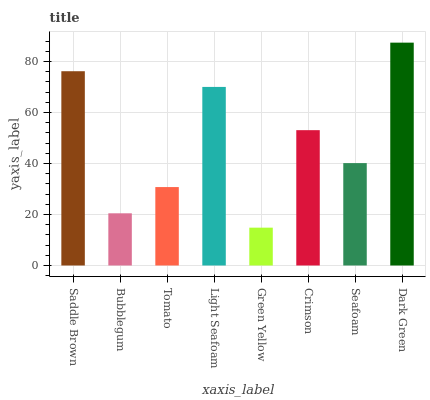Is Green Yellow the minimum?
Answer yes or no. Yes. Is Dark Green the maximum?
Answer yes or no. Yes. Is Bubblegum the minimum?
Answer yes or no. No. Is Bubblegum the maximum?
Answer yes or no. No. Is Saddle Brown greater than Bubblegum?
Answer yes or no. Yes. Is Bubblegum less than Saddle Brown?
Answer yes or no. Yes. Is Bubblegum greater than Saddle Brown?
Answer yes or no. No. Is Saddle Brown less than Bubblegum?
Answer yes or no. No. Is Crimson the high median?
Answer yes or no. Yes. Is Seafoam the low median?
Answer yes or no. Yes. Is Seafoam the high median?
Answer yes or no. No. Is Green Yellow the low median?
Answer yes or no. No. 